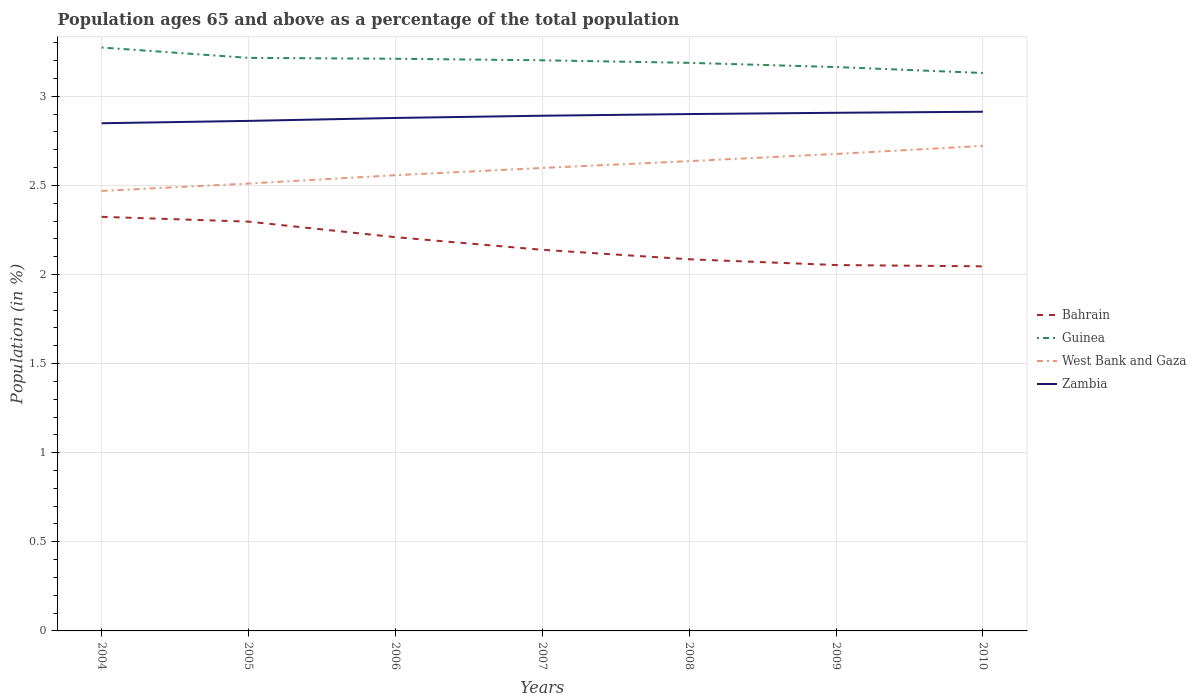How many different coloured lines are there?
Make the answer very short. 4. Is the number of lines equal to the number of legend labels?
Your answer should be very brief. Yes. Across all years, what is the maximum percentage of the population ages 65 and above in West Bank and Gaza?
Your answer should be compact. 2.47. In which year was the percentage of the population ages 65 and above in Zambia maximum?
Your response must be concise. 2004. What is the total percentage of the population ages 65 and above in Zambia in the graph?
Keep it short and to the point. -0.02. What is the difference between the highest and the second highest percentage of the population ages 65 and above in West Bank and Gaza?
Your answer should be very brief. 0.25. How many lines are there?
Your answer should be compact. 4. How many years are there in the graph?
Make the answer very short. 7. How many legend labels are there?
Provide a short and direct response. 4. What is the title of the graph?
Provide a short and direct response. Population ages 65 and above as a percentage of the total population. What is the Population (in %) in Bahrain in 2004?
Offer a very short reply. 2.32. What is the Population (in %) in Guinea in 2004?
Offer a terse response. 3.27. What is the Population (in %) of West Bank and Gaza in 2004?
Provide a succinct answer. 2.47. What is the Population (in %) of Zambia in 2004?
Offer a terse response. 2.85. What is the Population (in %) in Bahrain in 2005?
Give a very brief answer. 2.3. What is the Population (in %) in Guinea in 2005?
Keep it short and to the point. 3.22. What is the Population (in %) in West Bank and Gaza in 2005?
Keep it short and to the point. 2.51. What is the Population (in %) in Zambia in 2005?
Your answer should be compact. 2.86. What is the Population (in %) in Bahrain in 2006?
Your answer should be compact. 2.21. What is the Population (in %) of Guinea in 2006?
Your response must be concise. 3.21. What is the Population (in %) in West Bank and Gaza in 2006?
Provide a short and direct response. 2.56. What is the Population (in %) in Zambia in 2006?
Your response must be concise. 2.88. What is the Population (in %) in Bahrain in 2007?
Provide a short and direct response. 2.14. What is the Population (in %) of Guinea in 2007?
Your response must be concise. 3.2. What is the Population (in %) of West Bank and Gaza in 2007?
Make the answer very short. 2.6. What is the Population (in %) of Zambia in 2007?
Provide a short and direct response. 2.89. What is the Population (in %) in Bahrain in 2008?
Offer a terse response. 2.09. What is the Population (in %) in Guinea in 2008?
Your answer should be very brief. 3.19. What is the Population (in %) in West Bank and Gaza in 2008?
Offer a terse response. 2.64. What is the Population (in %) in Zambia in 2008?
Make the answer very short. 2.9. What is the Population (in %) of Bahrain in 2009?
Offer a terse response. 2.05. What is the Population (in %) in Guinea in 2009?
Provide a succinct answer. 3.16. What is the Population (in %) in West Bank and Gaza in 2009?
Your answer should be compact. 2.68. What is the Population (in %) of Zambia in 2009?
Give a very brief answer. 2.91. What is the Population (in %) in Bahrain in 2010?
Your response must be concise. 2.05. What is the Population (in %) of Guinea in 2010?
Your response must be concise. 3.13. What is the Population (in %) in West Bank and Gaza in 2010?
Your answer should be very brief. 2.72. What is the Population (in %) in Zambia in 2010?
Your response must be concise. 2.91. Across all years, what is the maximum Population (in %) in Bahrain?
Keep it short and to the point. 2.32. Across all years, what is the maximum Population (in %) of Guinea?
Make the answer very short. 3.27. Across all years, what is the maximum Population (in %) in West Bank and Gaza?
Your answer should be compact. 2.72. Across all years, what is the maximum Population (in %) of Zambia?
Provide a succinct answer. 2.91. Across all years, what is the minimum Population (in %) in Bahrain?
Provide a short and direct response. 2.05. Across all years, what is the minimum Population (in %) of Guinea?
Your response must be concise. 3.13. Across all years, what is the minimum Population (in %) in West Bank and Gaza?
Make the answer very short. 2.47. Across all years, what is the minimum Population (in %) in Zambia?
Your answer should be very brief. 2.85. What is the total Population (in %) in Bahrain in the graph?
Your answer should be very brief. 15.15. What is the total Population (in %) in Guinea in the graph?
Ensure brevity in your answer.  22.38. What is the total Population (in %) in West Bank and Gaza in the graph?
Your answer should be compact. 18.17. What is the total Population (in %) in Zambia in the graph?
Provide a succinct answer. 20.2. What is the difference between the Population (in %) of Bahrain in 2004 and that in 2005?
Provide a short and direct response. 0.03. What is the difference between the Population (in %) in Guinea in 2004 and that in 2005?
Ensure brevity in your answer.  0.06. What is the difference between the Population (in %) of West Bank and Gaza in 2004 and that in 2005?
Your answer should be very brief. -0.04. What is the difference between the Population (in %) of Zambia in 2004 and that in 2005?
Make the answer very short. -0.01. What is the difference between the Population (in %) in Bahrain in 2004 and that in 2006?
Your answer should be compact. 0.11. What is the difference between the Population (in %) in Guinea in 2004 and that in 2006?
Your answer should be compact. 0.06. What is the difference between the Population (in %) in West Bank and Gaza in 2004 and that in 2006?
Make the answer very short. -0.09. What is the difference between the Population (in %) of Zambia in 2004 and that in 2006?
Provide a succinct answer. -0.03. What is the difference between the Population (in %) in Bahrain in 2004 and that in 2007?
Your answer should be compact. 0.18. What is the difference between the Population (in %) in Guinea in 2004 and that in 2007?
Keep it short and to the point. 0.07. What is the difference between the Population (in %) of West Bank and Gaza in 2004 and that in 2007?
Provide a short and direct response. -0.13. What is the difference between the Population (in %) of Zambia in 2004 and that in 2007?
Provide a short and direct response. -0.04. What is the difference between the Population (in %) in Bahrain in 2004 and that in 2008?
Your response must be concise. 0.24. What is the difference between the Population (in %) in Guinea in 2004 and that in 2008?
Your response must be concise. 0.09. What is the difference between the Population (in %) in West Bank and Gaza in 2004 and that in 2008?
Keep it short and to the point. -0.17. What is the difference between the Population (in %) of Zambia in 2004 and that in 2008?
Make the answer very short. -0.05. What is the difference between the Population (in %) in Bahrain in 2004 and that in 2009?
Keep it short and to the point. 0.27. What is the difference between the Population (in %) of Guinea in 2004 and that in 2009?
Make the answer very short. 0.11. What is the difference between the Population (in %) in West Bank and Gaza in 2004 and that in 2009?
Your answer should be very brief. -0.21. What is the difference between the Population (in %) in Zambia in 2004 and that in 2009?
Give a very brief answer. -0.06. What is the difference between the Population (in %) in Bahrain in 2004 and that in 2010?
Provide a succinct answer. 0.28. What is the difference between the Population (in %) in Guinea in 2004 and that in 2010?
Your answer should be very brief. 0.14. What is the difference between the Population (in %) in West Bank and Gaza in 2004 and that in 2010?
Your answer should be compact. -0.25. What is the difference between the Population (in %) in Zambia in 2004 and that in 2010?
Provide a short and direct response. -0.06. What is the difference between the Population (in %) in Bahrain in 2005 and that in 2006?
Keep it short and to the point. 0.09. What is the difference between the Population (in %) of Guinea in 2005 and that in 2006?
Your response must be concise. 0. What is the difference between the Population (in %) of West Bank and Gaza in 2005 and that in 2006?
Ensure brevity in your answer.  -0.05. What is the difference between the Population (in %) in Zambia in 2005 and that in 2006?
Ensure brevity in your answer.  -0.02. What is the difference between the Population (in %) in Bahrain in 2005 and that in 2007?
Offer a terse response. 0.16. What is the difference between the Population (in %) of Guinea in 2005 and that in 2007?
Your answer should be very brief. 0.01. What is the difference between the Population (in %) of West Bank and Gaza in 2005 and that in 2007?
Make the answer very short. -0.09. What is the difference between the Population (in %) of Zambia in 2005 and that in 2007?
Offer a very short reply. -0.03. What is the difference between the Population (in %) of Bahrain in 2005 and that in 2008?
Your answer should be compact. 0.21. What is the difference between the Population (in %) of Guinea in 2005 and that in 2008?
Ensure brevity in your answer.  0.03. What is the difference between the Population (in %) in West Bank and Gaza in 2005 and that in 2008?
Give a very brief answer. -0.13. What is the difference between the Population (in %) in Zambia in 2005 and that in 2008?
Your answer should be compact. -0.04. What is the difference between the Population (in %) in Bahrain in 2005 and that in 2009?
Make the answer very short. 0.24. What is the difference between the Population (in %) of Guinea in 2005 and that in 2009?
Give a very brief answer. 0.05. What is the difference between the Population (in %) in West Bank and Gaza in 2005 and that in 2009?
Provide a succinct answer. -0.17. What is the difference between the Population (in %) in Zambia in 2005 and that in 2009?
Provide a short and direct response. -0.05. What is the difference between the Population (in %) of Bahrain in 2005 and that in 2010?
Give a very brief answer. 0.25. What is the difference between the Population (in %) in Guinea in 2005 and that in 2010?
Your response must be concise. 0.08. What is the difference between the Population (in %) in West Bank and Gaza in 2005 and that in 2010?
Offer a very short reply. -0.21. What is the difference between the Population (in %) of Zambia in 2005 and that in 2010?
Your answer should be compact. -0.05. What is the difference between the Population (in %) in Bahrain in 2006 and that in 2007?
Give a very brief answer. 0.07. What is the difference between the Population (in %) in Guinea in 2006 and that in 2007?
Make the answer very short. 0.01. What is the difference between the Population (in %) of West Bank and Gaza in 2006 and that in 2007?
Your answer should be very brief. -0.04. What is the difference between the Population (in %) of Zambia in 2006 and that in 2007?
Offer a terse response. -0.01. What is the difference between the Population (in %) in Bahrain in 2006 and that in 2008?
Give a very brief answer. 0.12. What is the difference between the Population (in %) of Guinea in 2006 and that in 2008?
Offer a very short reply. 0.02. What is the difference between the Population (in %) in West Bank and Gaza in 2006 and that in 2008?
Your answer should be compact. -0.08. What is the difference between the Population (in %) in Zambia in 2006 and that in 2008?
Provide a succinct answer. -0.02. What is the difference between the Population (in %) in Bahrain in 2006 and that in 2009?
Keep it short and to the point. 0.16. What is the difference between the Population (in %) of Guinea in 2006 and that in 2009?
Your answer should be very brief. 0.05. What is the difference between the Population (in %) of West Bank and Gaza in 2006 and that in 2009?
Provide a succinct answer. -0.12. What is the difference between the Population (in %) in Zambia in 2006 and that in 2009?
Offer a very short reply. -0.03. What is the difference between the Population (in %) in Bahrain in 2006 and that in 2010?
Your answer should be very brief. 0.16. What is the difference between the Population (in %) in Guinea in 2006 and that in 2010?
Your response must be concise. 0.08. What is the difference between the Population (in %) of West Bank and Gaza in 2006 and that in 2010?
Your answer should be very brief. -0.16. What is the difference between the Population (in %) in Zambia in 2006 and that in 2010?
Offer a very short reply. -0.03. What is the difference between the Population (in %) of Bahrain in 2007 and that in 2008?
Keep it short and to the point. 0.05. What is the difference between the Population (in %) of Guinea in 2007 and that in 2008?
Offer a very short reply. 0.01. What is the difference between the Population (in %) of West Bank and Gaza in 2007 and that in 2008?
Ensure brevity in your answer.  -0.04. What is the difference between the Population (in %) in Zambia in 2007 and that in 2008?
Provide a short and direct response. -0.01. What is the difference between the Population (in %) in Bahrain in 2007 and that in 2009?
Provide a short and direct response. 0.09. What is the difference between the Population (in %) of Guinea in 2007 and that in 2009?
Ensure brevity in your answer.  0.04. What is the difference between the Population (in %) in West Bank and Gaza in 2007 and that in 2009?
Give a very brief answer. -0.08. What is the difference between the Population (in %) in Zambia in 2007 and that in 2009?
Ensure brevity in your answer.  -0.02. What is the difference between the Population (in %) of Bahrain in 2007 and that in 2010?
Your answer should be very brief. 0.09. What is the difference between the Population (in %) of Guinea in 2007 and that in 2010?
Your answer should be very brief. 0.07. What is the difference between the Population (in %) in West Bank and Gaza in 2007 and that in 2010?
Make the answer very short. -0.12. What is the difference between the Population (in %) in Zambia in 2007 and that in 2010?
Offer a very short reply. -0.02. What is the difference between the Population (in %) of Bahrain in 2008 and that in 2009?
Your response must be concise. 0.03. What is the difference between the Population (in %) in Guinea in 2008 and that in 2009?
Provide a short and direct response. 0.02. What is the difference between the Population (in %) of West Bank and Gaza in 2008 and that in 2009?
Your answer should be compact. -0.04. What is the difference between the Population (in %) of Zambia in 2008 and that in 2009?
Your response must be concise. -0.01. What is the difference between the Population (in %) of Bahrain in 2008 and that in 2010?
Ensure brevity in your answer.  0.04. What is the difference between the Population (in %) in Guinea in 2008 and that in 2010?
Ensure brevity in your answer.  0.06. What is the difference between the Population (in %) in West Bank and Gaza in 2008 and that in 2010?
Provide a succinct answer. -0.09. What is the difference between the Population (in %) of Zambia in 2008 and that in 2010?
Your response must be concise. -0.01. What is the difference between the Population (in %) in Bahrain in 2009 and that in 2010?
Your answer should be compact. 0.01. What is the difference between the Population (in %) in Guinea in 2009 and that in 2010?
Make the answer very short. 0.03. What is the difference between the Population (in %) in West Bank and Gaza in 2009 and that in 2010?
Your answer should be compact. -0.05. What is the difference between the Population (in %) in Zambia in 2009 and that in 2010?
Your answer should be compact. -0.01. What is the difference between the Population (in %) in Bahrain in 2004 and the Population (in %) in Guinea in 2005?
Provide a short and direct response. -0.89. What is the difference between the Population (in %) in Bahrain in 2004 and the Population (in %) in West Bank and Gaza in 2005?
Give a very brief answer. -0.19. What is the difference between the Population (in %) of Bahrain in 2004 and the Population (in %) of Zambia in 2005?
Make the answer very short. -0.54. What is the difference between the Population (in %) of Guinea in 2004 and the Population (in %) of West Bank and Gaza in 2005?
Provide a short and direct response. 0.76. What is the difference between the Population (in %) in Guinea in 2004 and the Population (in %) in Zambia in 2005?
Provide a succinct answer. 0.41. What is the difference between the Population (in %) in West Bank and Gaza in 2004 and the Population (in %) in Zambia in 2005?
Your answer should be very brief. -0.39. What is the difference between the Population (in %) of Bahrain in 2004 and the Population (in %) of Guinea in 2006?
Keep it short and to the point. -0.89. What is the difference between the Population (in %) in Bahrain in 2004 and the Population (in %) in West Bank and Gaza in 2006?
Offer a very short reply. -0.23. What is the difference between the Population (in %) of Bahrain in 2004 and the Population (in %) of Zambia in 2006?
Offer a terse response. -0.55. What is the difference between the Population (in %) in Guinea in 2004 and the Population (in %) in West Bank and Gaza in 2006?
Your answer should be compact. 0.72. What is the difference between the Population (in %) of Guinea in 2004 and the Population (in %) of Zambia in 2006?
Your response must be concise. 0.4. What is the difference between the Population (in %) in West Bank and Gaza in 2004 and the Population (in %) in Zambia in 2006?
Provide a succinct answer. -0.41. What is the difference between the Population (in %) of Bahrain in 2004 and the Population (in %) of Guinea in 2007?
Make the answer very short. -0.88. What is the difference between the Population (in %) of Bahrain in 2004 and the Population (in %) of West Bank and Gaza in 2007?
Give a very brief answer. -0.27. What is the difference between the Population (in %) in Bahrain in 2004 and the Population (in %) in Zambia in 2007?
Your response must be concise. -0.57. What is the difference between the Population (in %) in Guinea in 2004 and the Population (in %) in West Bank and Gaza in 2007?
Your answer should be compact. 0.68. What is the difference between the Population (in %) of Guinea in 2004 and the Population (in %) of Zambia in 2007?
Your response must be concise. 0.38. What is the difference between the Population (in %) in West Bank and Gaza in 2004 and the Population (in %) in Zambia in 2007?
Your answer should be compact. -0.42. What is the difference between the Population (in %) in Bahrain in 2004 and the Population (in %) in Guinea in 2008?
Keep it short and to the point. -0.86. What is the difference between the Population (in %) in Bahrain in 2004 and the Population (in %) in West Bank and Gaza in 2008?
Keep it short and to the point. -0.31. What is the difference between the Population (in %) in Bahrain in 2004 and the Population (in %) in Zambia in 2008?
Keep it short and to the point. -0.58. What is the difference between the Population (in %) in Guinea in 2004 and the Population (in %) in West Bank and Gaza in 2008?
Your answer should be compact. 0.64. What is the difference between the Population (in %) of Guinea in 2004 and the Population (in %) of Zambia in 2008?
Provide a succinct answer. 0.37. What is the difference between the Population (in %) in West Bank and Gaza in 2004 and the Population (in %) in Zambia in 2008?
Provide a short and direct response. -0.43. What is the difference between the Population (in %) in Bahrain in 2004 and the Population (in %) in Guinea in 2009?
Your answer should be compact. -0.84. What is the difference between the Population (in %) in Bahrain in 2004 and the Population (in %) in West Bank and Gaza in 2009?
Provide a succinct answer. -0.35. What is the difference between the Population (in %) of Bahrain in 2004 and the Population (in %) of Zambia in 2009?
Your answer should be very brief. -0.58. What is the difference between the Population (in %) in Guinea in 2004 and the Population (in %) in West Bank and Gaza in 2009?
Offer a terse response. 0.6. What is the difference between the Population (in %) of Guinea in 2004 and the Population (in %) of Zambia in 2009?
Your answer should be compact. 0.37. What is the difference between the Population (in %) in West Bank and Gaza in 2004 and the Population (in %) in Zambia in 2009?
Offer a very short reply. -0.44. What is the difference between the Population (in %) in Bahrain in 2004 and the Population (in %) in Guinea in 2010?
Ensure brevity in your answer.  -0.81. What is the difference between the Population (in %) of Bahrain in 2004 and the Population (in %) of West Bank and Gaza in 2010?
Give a very brief answer. -0.4. What is the difference between the Population (in %) of Bahrain in 2004 and the Population (in %) of Zambia in 2010?
Ensure brevity in your answer.  -0.59. What is the difference between the Population (in %) in Guinea in 2004 and the Population (in %) in West Bank and Gaza in 2010?
Your answer should be very brief. 0.55. What is the difference between the Population (in %) in Guinea in 2004 and the Population (in %) in Zambia in 2010?
Your response must be concise. 0.36. What is the difference between the Population (in %) in West Bank and Gaza in 2004 and the Population (in %) in Zambia in 2010?
Your answer should be very brief. -0.44. What is the difference between the Population (in %) in Bahrain in 2005 and the Population (in %) in Guinea in 2006?
Give a very brief answer. -0.91. What is the difference between the Population (in %) in Bahrain in 2005 and the Population (in %) in West Bank and Gaza in 2006?
Give a very brief answer. -0.26. What is the difference between the Population (in %) in Bahrain in 2005 and the Population (in %) in Zambia in 2006?
Ensure brevity in your answer.  -0.58. What is the difference between the Population (in %) of Guinea in 2005 and the Population (in %) of West Bank and Gaza in 2006?
Provide a short and direct response. 0.66. What is the difference between the Population (in %) of Guinea in 2005 and the Population (in %) of Zambia in 2006?
Your answer should be compact. 0.34. What is the difference between the Population (in %) of West Bank and Gaza in 2005 and the Population (in %) of Zambia in 2006?
Offer a terse response. -0.37. What is the difference between the Population (in %) of Bahrain in 2005 and the Population (in %) of Guinea in 2007?
Ensure brevity in your answer.  -0.91. What is the difference between the Population (in %) of Bahrain in 2005 and the Population (in %) of West Bank and Gaza in 2007?
Keep it short and to the point. -0.3. What is the difference between the Population (in %) in Bahrain in 2005 and the Population (in %) in Zambia in 2007?
Your answer should be very brief. -0.59. What is the difference between the Population (in %) of Guinea in 2005 and the Population (in %) of West Bank and Gaza in 2007?
Keep it short and to the point. 0.62. What is the difference between the Population (in %) of Guinea in 2005 and the Population (in %) of Zambia in 2007?
Give a very brief answer. 0.32. What is the difference between the Population (in %) in West Bank and Gaza in 2005 and the Population (in %) in Zambia in 2007?
Offer a terse response. -0.38. What is the difference between the Population (in %) in Bahrain in 2005 and the Population (in %) in Guinea in 2008?
Provide a succinct answer. -0.89. What is the difference between the Population (in %) of Bahrain in 2005 and the Population (in %) of West Bank and Gaza in 2008?
Offer a terse response. -0.34. What is the difference between the Population (in %) of Bahrain in 2005 and the Population (in %) of Zambia in 2008?
Your answer should be compact. -0.6. What is the difference between the Population (in %) in Guinea in 2005 and the Population (in %) in West Bank and Gaza in 2008?
Ensure brevity in your answer.  0.58. What is the difference between the Population (in %) in Guinea in 2005 and the Population (in %) in Zambia in 2008?
Offer a very short reply. 0.32. What is the difference between the Population (in %) of West Bank and Gaza in 2005 and the Population (in %) of Zambia in 2008?
Ensure brevity in your answer.  -0.39. What is the difference between the Population (in %) in Bahrain in 2005 and the Population (in %) in Guinea in 2009?
Provide a succinct answer. -0.87. What is the difference between the Population (in %) in Bahrain in 2005 and the Population (in %) in West Bank and Gaza in 2009?
Offer a terse response. -0.38. What is the difference between the Population (in %) in Bahrain in 2005 and the Population (in %) in Zambia in 2009?
Make the answer very short. -0.61. What is the difference between the Population (in %) in Guinea in 2005 and the Population (in %) in West Bank and Gaza in 2009?
Provide a short and direct response. 0.54. What is the difference between the Population (in %) in Guinea in 2005 and the Population (in %) in Zambia in 2009?
Your answer should be compact. 0.31. What is the difference between the Population (in %) in West Bank and Gaza in 2005 and the Population (in %) in Zambia in 2009?
Ensure brevity in your answer.  -0.4. What is the difference between the Population (in %) in Bahrain in 2005 and the Population (in %) in Guinea in 2010?
Make the answer very short. -0.83. What is the difference between the Population (in %) in Bahrain in 2005 and the Population (in %) in West Bank and Gaza in 2010?
Provide a succinct answer. -0.42. What is the difference between the Population (in %) in Bahrain in 2005 and the Population (in %) in Zambia in 2010?
Provide a succinct answer. -0.62. What is the difference between the Population (in %) in Guinea in 2005 and the Population (in %) in West Bank and Gaza in 2010?
Provide a succinct answer. 0.49. What is the difference between the Population (in %) of Guinea in 2005 and the Population (in %) of Zambia in 2010?
Give a very brief answer. 0.3. What is the difference between the Population (in %) in West Bank and Gaza in 2005 and the Population (in %) in Zambia in 2010?
Offer a terse response. -0.4. What is the difference between the Population (in %) of Bahrain in 2006 and the Population (in %) of Guinea in 2007?
Your answer should be compact. -0.99. What is the difference between the Population (in %) in Bahrain in 2006 and the Population (in %) in West Bank and Gaza in 2007?
Your response must be concise. -0.39. What is the difference between the Population (in %) in Bahrain in 2006 and the Population (in %) in Zambia in 2007?
Offer a very short reply. -0.68. What is the difference between the Population (in %) of Guinea in 2006 and the Population (in %) of West Bank and Gaza in 2007?
Provide a short and direct response. 0.61. What is the difference between the Population (in %) in Guinea in 2006 and the Population (in %) in Zambia in 2007?
Provide a succinct answer. 0.32. What is the difference between the Population (in %) in West Bank and Gaza in 2006 and the Population (in %) in Zambia in 2007?
Provide a short and direct response. -0.33. What is the difference between the Population (in %) of Bahrain in 2006 and the Population (in %) of Guinea in 2008?
Make the answer very short. -0.98. What is the difference between the Population (in %) of Bahrain in 2006 and the Population (in %) of West Bank and Gaza in 2008?
Your answer should be compact. -0.43. What is the difference between the Population (in %) in Bahrain in 2006 and the Population (in %) in Zambia in 2008?
Your response must be concise. -0.69. What is the difference between the Population (in %) in Guinea in 2006 and the Population (in %) in West Bank and Gaza in 2008?
Ensure brevity in your answer.  0.57. What is the difference between the Population (in %) in Guinea in 2006 and the Population (in %) in Zambia in 2008?
Keep it short and to the point. 0.31. What is the difference between the Population (in %) of West Bank and Gaza in 2006 and the Population (in %) of Zambia in 2008?
Your response must be concise. -0.34. What is the difference between the Population (in %) in Bahrain in 2006 and the Population (in %) in Guinea in 2009?
Make the answer very short. -0.95. What is the difference between the Population (in %) in Bahrain in 2006 and the Population (in %) in West Bank and Gaza in 2009?
Your answer should be very brief. -0.47. What is the difference between the Population (in %) in Bahrain in 2006 and the Population (in %) in Zambia in 2009?
Your answer should be compact. -0.7. What is the difference between the Population (in %) of Guinea in 2006 and the Population (in %) of West Bank and Gaza in 2009?
Give a very brief answer. 0.53. What is the difference between the Population (in %) in Guinea in 2006 and the Population (in %) in Zambia in 2009?
Give a very brief answer. 0.3. What is the difference between the Population (in %) of West Bank and Gaza in 2006 and the Population (in %) of Zambia in 2009?
Offer a terse response. -0.35. What is the difference between the Population (in %) in Bahrain in 2006 and the Population (in %) in Guinea in 2010?
Your answer should be very brief. -0.92. What is the difference between the Population (in %) of Bahrain in 2006 and the Population (in %) of West Bank and Gaza in 2010?
Your response must be concise. -0.51. What is the difference between the Population (in %) of Bahrain in 2006 and the Population (in %) of Zambia in 2010?
Ensure brevity in your answer.  -0.7. What is the difference between the Population (in %) of Guinea in 2006 and the Population (in %) of West Bank and Gaza in 2010?
Ensure brevity in your answer.  0.49. What is the difference between the Population (in %) in Guinea in 2006 and the Population (in %) in Zambia in 2010?
Ensure brevity in your answer.  0.3. What is the difference between the Population (in %) of West Bank and Gaza in 2006 and the Population (in %) of Zambia in 2010?
Ensure brevity in your answer.  -0.36. What is the difference between the Population (in %) of Bahrain in 2007 and the Population (in %) of Guinea in 2008?
Give a very brief answer. -1.05. What is the difference between the Population (in %) of Bahrain in 2007 and the Population (in %) of West Bank and Gaza in 2008?
Provide a short and direct response. -0.5. What is the difference between the Population (in %) of Bahrain in 2007 and the Population (in %) of Zambia in 2008?
Offer a very short reply. -0.76. What is the difference between the Population (in %) in Guinea in 2007 and the Population (in %) in West Bank and Gaza in 2008?
Keep it short and to the point. 0.57. What is the difference between the Population (in %) of Guinea in 2007 and the Population (in %) of Zambia in 2008?
Offer a very short reply. 0.3. What is the difference between the Population (in %) of West Bank and Gaza in 2007 and the Population (in %) of Zambia in 2008?
Offer a very short reply. -0.3. What is the difference between the Population (in %) of Bahrain in 2007 and the Population (in %) of Guinea in 2009?
Keep it short and to the point. -1.03. What is the difference between the Population (in %) in Bahrain in 2007 and the Population (in %) in West Bank and Gaza in 2009?
Your response must be concise. -0.54. What is the difference between the Population (in %) in Bahrain in 2007 and the Population (in %) in Zambia in 2009?
Make the answer very short. -0.77. What is the difference between the Population (in %) in Guinea in 2007 and the Population (in %) in West Bank and Gaza in 2009?
Ensure brevity in your answer.  0.53. What is the difference between the Population (in %) in Guinea in 2007 and the Population (in %) in Zambia in 2009?
Provide a short and direct response. 0.29. What is the difference between the Population (in %) of West Bank and Gaza in 2007 and the Population (in %) of Zambia in 2009?
Offer a terse response. -0.31. What is the difference between the Population (in %) in Bahrain in 2007 and the Population (in %) in Guinea in 2010?
Provide a succinct answer. -0.99. What is the difference between the Population (in %) of Bahrain in 2007 and the Population (in %) of West Bank and Gaza in 2010?
Offer a very short reply. -0.58. What is the difference between the Population (in %) of Bahrain in 2007 and the Population (in %) of Zambia in 2010?
Provide a short and direct response. -0.77. What is the difference between the Population (in %) of Guinea in 2007 and the Population (in %) of West Bank and Gaza in 2010?
Offer a terse response. 0.48. What is the difference between the Population (in %) in Guinea in 2007 and the Population (in %) in Zambia in 2010?
Provide a succinct answer. 0.29. What is the difference between the Population (in %) of West Bank and Gaza in 2007 and the Population (in %) of Zambia in 2010?
Ensure brevity in your answer.  -0.32. What is the difference between the Population (in %) of Bahrain in 2008 and the Population (in %) of Guinea in 2009?
Your answer should be very brief. -1.08. What is the difference between the Population (in %) of Bahrain in 2008 and the Population (in %) of West Bank and Gaza in 2009?
Your response must be concise. -0.59. What is the difference between the Population (in %) in Bahrain in 2008 and the Population (in %) in Zambia in 2009?
Offer a very short reply. -0.82. What is the difference between the Population (in %) in Guinea in 2008 and the Population (in %) in West Bank and Gaza in 2009?
Make the answer very short. 0.51. What is the difference between the Population (in %) of Guinea in 2008 and the Population (in %) of Zambia in 2009?
Make the answer very short. 0.28. What is the difference between the Population (in %) in West Bank and Gaza in 2008 and the Population (in %) in Zambia in 2009?
Your answer should be very brief. -0.27. What is the difference between the Population (in %) in Bahrain in 2008 and the Population (in %) in Guinea in 2010?
Provide a succinct answer. -1.05. What is the difference between the Population (in %) in Bahrain in 2008 and the Population (in %) in West Bank and Gaza in 2010?
Give a very brief answer. -0.64. What is the difference between the Population (in %) in Bahrain in 2008 and the Population (in %) in Zambia in 2010?
Your response must be concise. -0.83. What is the difference between the Population (in %) in Guinea in 2008 and the Population (in %) in West Bank and Gaza in 2010?
Your response must be concise. 0.47. What is the difference between the Population (in %) in Guinea in 2008 and the Population (in %) in Zambia in 2010?
Offer a very short reply. 0.27. What is the difference between the Population (in %) of West Bank and Gaza in 2008 and the Population (in %) of Zambia in 2010?
Your answer should be compact. -0.28. What is the difference between the Population (in %) in Bahrain in 2009 and the Population (in %) in Guinea in 2010?
Your answer should be compact. -1.08. What is the difference between the Population (in %) in Bahrain in 2009 and the Population (in %) in West Bank and Gaza in 2010?
Offer a terse response. -0.67. What is the difference between the Population (in %) of Bahrain in 2009 and the Population (in %) of Zambia in 2010?
Make the answer very short. -0.86. What is the difference between the Population (in %) of Guinea in 2009 and the Population (in %) of West Bank and Gaza in 2010?
Keep it short and to the point. 0.44. What is the difference between the Population (in %) of Guinea in 2009 and the Population (in %) of Zambia in 2010?
Keep it short and to the point. 0.25. What is the difference between the Population (in %) of West Bank and Gaza in 2009 and the Population (in %) of Zambia in 2010?
Your answer should be very brief. -0.24. What is the average Population (in %) in Bahrain per year?
Offer a very short reply. 2.16. What is the average Population (in %) of Guinea per year?
Your answer should be very brief. 3.2. What is the average Population (in %) of West Bank and Gaza per year?
Keep it short and to the point. 2.6. What is the average Population (in %) in Zambia per year?
Your answer should be very brief. 2.89. In the year 2004, what is the difference between the Population (in %) of Bahrain and Population (in %) of Guinea?
Ensure brevity in your answer.  -0.95. In the year 2004, what is the difference between the Population (in %) of Bahrain and Population (in %) of West Bank and Gaza?
Offer a very short reply. -0.15. In the year 2004, what is the difference between the Population (in %) of Bahrain and Population (in %) of Zambia?
Provide a succinct answer. -0.53. In the year 2004, what is the difference between the Population (in %) of Guinea and Population (in %) of West Bank and Gaza?
Provide a succinct answer. 0.8. In the year 2004, what is the difference between the Population (in %) of Guinea and Population (in %) of Zambia?
Your response must be concise. 0.42. In the year 2004, what is the difference between the Population (in %) in West Bank and Gaza and Population (in %) in Zambia?
Provide a short and direct response. -0.38. In the year 2005, what is the difference between the Population (in %) in Bahrain and Population (in %) in Guinea?
Your answer should be very brief. -0.92. In the year 2005, what is the difference between the Population (in %) of Bahrain and Population (in %) of West Bank and Gaza?
Provide a short and direct response. -0.21. In the year 2005, what is the difference between the Population (in %) of Bahrain and Population (in %) of Zambia?
Give a very brief answer. -0.57. In the year 2005, what is the difference between the Population (in %) of Guinea and Population (in %) of West Bank and Gaza?
Keep it short and to the point. 0.71. In the year 2005, what is the difference between the Population (in %) of Guinea and Population (in %) of Zambia?
Ensure brevity in your answer.  0.35. In the year 2005, what is the difference between the Population (in %) of West Bank and Gaza and Population (in %) of Zambia?
Your answer should be very brief. -0.35. In the year 2006, what is the difference between the Population (in %) in Bahrain and Population (in %) in Guinea?
Keep it short and to the point. -1. In the year 2006, what is the difference between the Population (in %) of Bahrain and Population (in %) of West Bank and Gaza?
Make the answer very short. -0.35. In the year 2006, what is the difference between the Population (in %) in Bahrain and Population (in %) in Zambia?
Ensure brevity in your answer.  -0.67. In the year 2006, what is the difference between the Population (in %) of Guinea and Population (in %) of West Bank and Gaza?
Give a very brief answer. 0.65. In the year 2006, what is the difference between the Population (in %) in Guinea and Population (in %) in Zambia?
Offer a terse response. 0.33. In the year 2006, what is the difference between the Population (in %) of West Bank and Gaza and Population (in %) of Zambia?
Your response must be concise. -0.32. In the year 2007, what is the difference between the Population (in %) of Bahrain and Population (in %) of Guinea?
Ensure brevity in your answer.  -1.06. In the year 2007, what is the difference between the Population (in %) in Bahrain and Population (in %) in West Bank and Gaza?
Offer a very short reply. -0.46. In the year 2007, what is the difference between the Population (in %) of Bahrain and Population (in %) of Zambia?
Your answer should be compact. -0.75. In the year 2007, what is the difference between the Population (in %) in Guinea and Population (in %) in West Bank and Gaza?
Make the answer very short. 0.6. In the year 2007, what is the difference between the Population (in %) in Guinea and Population (in %) in Zambia?
Provide a short and direct response. 0.31. In the year 2007, what is the difference between the Population (in %) in West Bank and Gaza and Population (in %) in Zambia?
Offer a very short reply. -0.29. In the year 2008, what is the difference between the Population (in %) in Bahrain and Population (in %) in Guinea?
Keep it short and to the point. -1.1. In the year 2008, what is the difference between the Population (in %) of Bahrain and Population (in %) of West Bank and Gaza?
Offer a terse response. -0.55. In the year 2008, what is the difference between the Population (in %) of Bahrain and Population (in %) of Zambia?
Ensure brevity in your answer.  -0.81. In the year 2008, what is the difference between the Population (in %) of Guinea and Population (in %) of West Bank and Gaza?
Keep it short and to the point. 0.55. In the year 2008, what is the difference between the Population (in %) of Guinea and Population (in %) of Zambia?
Your answer should be very brief. 0.29. In the year 2008, what is the difference between the Population (in %) in West Bank and Gaza and Population (in %) in Zambia?
Your answer should be very brief. -0.26. In the year 2009, what is the difference between the Population (in %) in Bahrain and Population (in %) in Guinea?
Offer a terse response. -1.11. In the year 2009, what is the difference between the Population (in %) of Bahrain and Population (in %) of West Bank and Gaza?
Keep it short and to the point. -0.62. In the year 2009, what is the difference between the Population (in %) in Bahrain and Population (in %) in Zambia?
Ensure brevity in your answer.  -0.85. In the year 2009, what is the difference between the Population (in %) in Guinea and Population (in %) in West Bank and Gaza?
Give a very brief answer. 0.49. In the year 2009, what is the difference between the Population (in %) of Guinea and Population (in %) of Zambia?
Offer a terse response. 0.26. In the year 2009, what is the difference between the Population (in %) of West Bank and Gaza and Population (in %) of Zambia?
Offer a very short reply. -0.23. In the year 2010, what is the difference between the Population (in %) in Bahrain and Population (in %) in Guinea?
Make the answer very short. -1.08. In the year 2010, what is the difference between the Population (in %) in Bahrain and Population (in %) in West Bank and Gaza?
Your answer should be compact. -0.68. In the year 2010, what is the difference between the Population (in %) of Bahrain and Population (in %) of Zambia?
Your answer should be compact. -0.87. In the year 2010, what is the difference between the Population (in %) of Guinea and Population (in %) of West Bank and Gaza?
Your response must be concise. 0.41. In the year 2010, what is the difference between the Population (in %) in Guinea and Population (in %) in Zambia?
Provide a succinct answer. 0.22. In the year 2010, what is the difference between the Population (in %) in West Bank and Gaza and Population (in %) in Zambia?
Your answer should be very brief. -0.19. What is the ratio of the Population (in %) in Bahrain in 2004 to that in 2005?
Provide a short and direct response. 1.01. What is the ratio of the Population (in %) of Guinea in 2004 to that in 2005?
Make the answer very short. 1.02. What is the ratio of the Population (in %) in West Bank and Gaza in 2004 to that in 2005?
Your answer should be compact. 0.98. What is the ratio of the Population (in %) of Bahrain in 2004 to that in 2006?
Ensure brevity in your answer.  1.05. What is the ratio of the Population (in %) of Guinea in 2004 to that in 2006?
Give a very brief answer. 1.02. What is the ratio of the Population (in %) of West Bank and Gaza in 2004 to that in 2006?
Ensure brevity in your answer.  0.97. What is the ratio of the Population (in %) in Zambia in 2004 to that in 2006?
Keep it short and to the point. 0.99. What is the ratio of the Population (in %) in Bahrain in 2004 to that in 2007?
Ensure brevity in your answer.  1.09. What is the ratio of the Population (in %) of Guinea in 2004 to that in 2007?
Make the answer very short. 1.02. What is the ratio of the Population (in %) in West Bank and Gaza in 2004 to that in 2007?
Provide a succinct answer. 0.95. What is the ratio of the Population (in %) in Zambia in 2004 to that in 2007?
Provide a short and direct response. 0.99. What is the ratio of the Population (in %) in Bahrain in 2004 to that in 2008?
Provide a succinct answer. 1.11. What is the ratio of the Population (in %) of West Bank and Gaza in 2004 to that in 2008?
Offer a terse response. 0.94. What is the ratio of the Population (in %) of Zambia in 2004 to that in 2008?
Your response must be concise. 0.98. What is the ratio of the Population (in %) of Bahrain in 2004 to that in 2009?
Make the answer very short. 1.13. What is the ratio of the Population (in %) of Guinea in 2004 to that in 2009?
Provide a succinct answer. 1.03. What is the ratio of the Population (in %) in West Bank and Gaza in 2004 to that in 2009?
Keep it short and to the point. 0.92. What is the ratio of the Population (in %) of Zambia in 2004 to that in 2009?
Provide a short and direct response. 0.98. What is the ratio of the Population (in %) of Bahrain in 2004 to that in 2010?
Your answer should be very brief. 1.14. What is the ratio of the Population (in %) of Guinea in 2004 to that in 2010?
Give a very brief answer. 1.05. What is the ratio of the Population (in %) in West Bank and Gaza in 2004 to that in 2010?
Your answer should be compact. 0.91. What is the ratio of the Population (in %) of Zambia in 2004 to that in 2010?
Offer a very short reply. 0.98. What is the ratio of the Population (in %) in Bahrain in 2005 to that in 2006?
Provide a succinct answer. 1.04. What is the ratio of the Population (in %) of West Bank and Gaza in 2005 to that in 2006?
Your answer should be very brief. 0.98. What is the ratio of the Population (in %) in Bahrain in 2005 to that in 2007?
Your response must be concise. 1.07. What is the ratio of the Population (in %) of West Bank and Gaza in 2005 to that in 2007?
Ensure brevity in your answer.  0.97. What is the ratio of the Population (in %) of Bahrain in 2005 to that in 2008?
Offer a terse response. 1.1. What is the ratio of the Population (in %) of Guinea in 2005 to that in 2008?
Your response must be concise. 1.01. What is the ratio of the Population (in %) in West Bank and Gaza in 2005 to that in 2008?
Your answer should be very brief. 0.95. What is the ratio of the Population (in %) of Bahrain in 2005 to that in 2009?
Offer a terse response. 1.12. What is the ratio of the Population (in %) of Guinea in 2005 to that in 2009?
Offer a very short reply. 1.02. What is the ratio of the Population (in %) in West Bank and Gaza in 2005 to that in 2009?
Offer a terse response. 0.94. What is the ratio of the Population (in %) of Zambia in 2005 to that in 2009?
Provide a succinct answer. 0.98. What is the ratio of the Population (in %) in Bahrain in 2005 to that in 2010?
Your answer should be compact. 1.12. What is the ratio of the Population (in %) of Guinea in 2005 to that in 2010?
Offer a very short reply. 1.03. What is the ratio of the Population (in %) in West Bank and Gaza in 2005 to that in 2010?
Provide a short and direct response. 0.92. What is the ratio of the Population (in %) of Zambia in 2005 to that in 2010?
Your answer should be compact. 0.98. What is the ratio of the Population (in %) in Bahrain in 2006 to that in 2007?
Your answer should be very brief. 1.03. What is the ratio of the Population (in %) in Guinea in 2006 to that in 2007?
Keep it short and to the point. 1. What is the ratio of the Population (in %) in West Bank and Gaza in 2006 to that in 2007?
Your response must be concise. 0.98. What is the ratio of the Population (in %) in Zambia in 2006 to that in 2007?
Your answer should be very brief. 1. What is the ratio of the Population (in %) in Bahrain in 2006 to that in 2008?
Keep it short and to the point. 1.06. What is the ratio of the Population (in %) of West Bank and Gaza in 2006 to that in 2008?
Your answer should be very brief. 0.97. What is the ratio of the Population (in %) in Zambia in 2006 to that in 2008?
Offer a very short reply. 0.99. What is the ratio of the Population (in %) of Bahrain in 2006 to that in 2009?
Give a very brief answer. 1.08. What is the ratio of the Population (in %) in Guinea in 2006 to that in 2009?
Your response must be concise. 1.01. What is the ratio of the Population (in %) in West Bank and Gaza in 2006 to that in 2009?
Keep it short and to the point. 0.96. What is the ratio of the Population (in %) in Zambia in 2006 to that in 2009?
Give a very brief answer. 0.99. What is the ratio of the Population (in %) of Guinea in 2006 to that in 2010?
Make the answer very short. 1.03. What is the ratio of the Population (in %) of West Bank and Gaza in 2006 to that in 2010?
Your answer should be very brief. 0.94. What is the ratio of the Population (in %) in Zambia in 2006 to that in 2010?
Provide a short and direct response. 0.99. What is the ratio of the Population (in %) of Bahrain in 2007 to that in 2008?
Offer a very short reply. 1.03. What is the ratio of the Population (in %) of Guinea in 2007 to that in 2008?
Keep it short and to the point. 1. What is the ratio of the Population (in %) in West Bank and Gaza in 2007 to that in 2008?
Your response must be concise. 0.99. What is the ratio of the Population (in %) of Zambia in 2007 to that in 2008?
Ensure brevity in your answer.  1. What is the ratio of the Population (in %) of Bahrain in 2007 to that in 2009?
Offer a very short reply. 1.04. What is the ratio of the Population (in %) in Guinea in 2007 to that in 2009?
Your answer should be very brief. 1.01. What is the ratio of the Population (in %) of West Bank and Gaza in 2007 to that in 2009?
Make the answer very short. 0.97. What is the ratio of the Population (in %) of Bahrain in 2007 to that in 2010?
Your answer should be compact. 1.05. What is the ratio of the Population (in %) of Guinea in 2007 to that in 2010?
Ensure brevity in your answer.  1.02. What is the ratio of the Population (in %) in West Bank and Gaza in 2007 to that in 2010?
Provide a succinct answer. 0.95. What is the ratio of the Population (in %) in Bahrain in 2008 to that in 2009?
Keep it short and to the point. 1.02. What is the ratio of the Population (in %) of Guinea in 2008 to that in 2009?
Provide a succinct answer. 1.01. What is the ratio of the Population (in %) in West Bank and Gaza in 2008 to that in 2009?
Keep it short and to the point. 0.98. What is the ratio of the Population (in %) of Zambia in 2008 to that in 2009?
Ensure brevity in your answer.  1. What is the ratio of the Population (in %) of Bahrain in 2008 to that in 2010?
Give a very brief answer. 1.02. What is the ratio of the Population (in %) in Guinea in 2008 to that in 2010?
Provide a short and direct response. 1.02. What is the ratio of the Population (in %) in West Bank and Gaza in 2008 to that in 2010?
Make the answer very short. 0.97. What is the ratio of the Population (in %) in Zambia in 2008 to that in 2010?
Ensure brevity in your answer.  1. What is the ratio of the Population (in %) of Guinea in 2009 to that in 2010?
Provide a succinct answer. 1.01. What is the ratio of the Population (in %) in West Bank and Gaza in 2009 to that in 2010?
Give a very brief answer. 0.98. What is the ratio of the Population (in %) in Zambia in 2009 to that in 2010?
Offer a terse response. 1. What is the difference between the highest and the second highest Population (in %) in Bahrain?
Provide a short and direct response. 0.03. What is the difference between the highest and the second highest Population (in %) in Guinea?
Your response must be concise. 0.06. What is the difference between the highest and the second highest Population (in %) in West Bank and Gaza?
Make the answer very short. 0.05. What is the difference between the highest and the second highest Population (in %) in Zambia?
Your response must be concise. 0.01. What is the difference between the highest and the lowest Population (in %) in Bahrain?
Give a very brief answer. 0.28. What is the difference between the highest and the lowest Population (in %) of Guinea?
Your answer should be very brief. 0.14. What is the difference between the highest and the lowest Population (in %) in West Bank and Gaza?
Offer a terse response. 0.25. What is the difference between the highest and the lowest Population (in %) of Zambia?
Offer a very short reply. 0.06. 